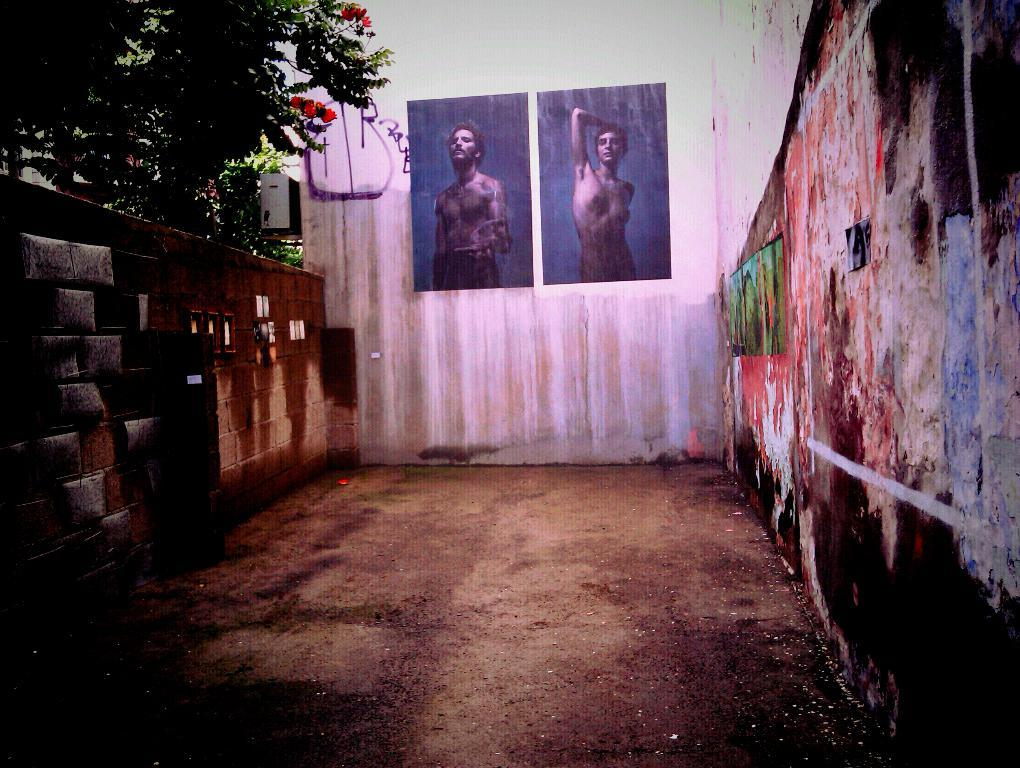What type of structure is located on the left side of the image? There is a brick wall on the left side of the image. What can be seen near the brick wall? There are trees near the brick wall. What is visible in the background of the image? There is a wall with posters in the background of the image. What do the posters depict? The posters depict a man and a woman. What is located on the right side of the image? There is a wall on the right side of the image. How many tomatoes are hanging from the wall on the right side of the image? There are no tomatoes present in the image. What advice is given by the man and woman depicted on the posters? The image does not provide any information about the advice given by the man and woman on the posters. 